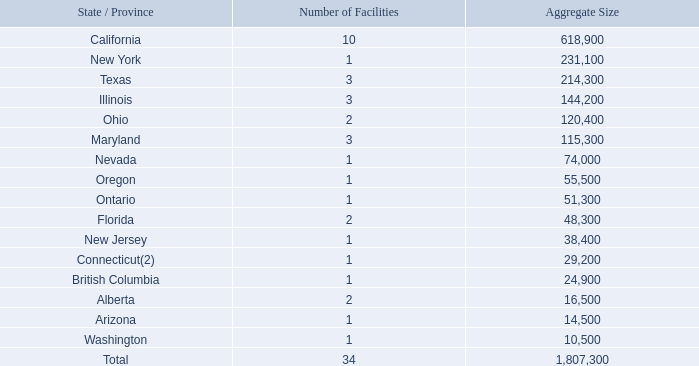Item 2. PROPERTIES
We operate 31 distributions centers located in the United States and Canada totaling approximately 1.7 million square feet. We own a 59,500 square foot distribution center in Cincinnati, Ohio and a 10,000 square foot protein processing facility and distribution center in Chicago, Illinois. All of our other properties are leased. The following table sets forth our distribution, protein processing, corporate and other support facilities by state or province and their approximate aggregate square footage as of February 21, 2020 (1).
(1)  Excludes the impact of our recent acquisitions of Sid Wainer & Son and Cambridge Packing Co, Inc. more fully described in 'Management's Discussion and Financial Condition and Results of Operations — Overview and Recent Developments."
(2)  Represents our corporate headquarters in Ridgefield, Connecticut.
We consider our properties to be in good condition generally and believe our facilities are adequate for our operations and provide sufficient capacity to meet our anticipated requirements.
What is the number of facilities in California and New York respectively? 10, 1. What is the number of facilities in Texas and Illinois respectively? 3, 3. What is the number of facilities in Ohio and Maryland respectively? 2, 3. What is the difference in the number of facilities between California and New York? 10-1
Answer: 9. What is the average aggregate size of the facilities in Arizona and Washington? (14,500+ 10,500)/2
Answer: 12500. How many states have more than 5 facilities? California
Answer: 1. 